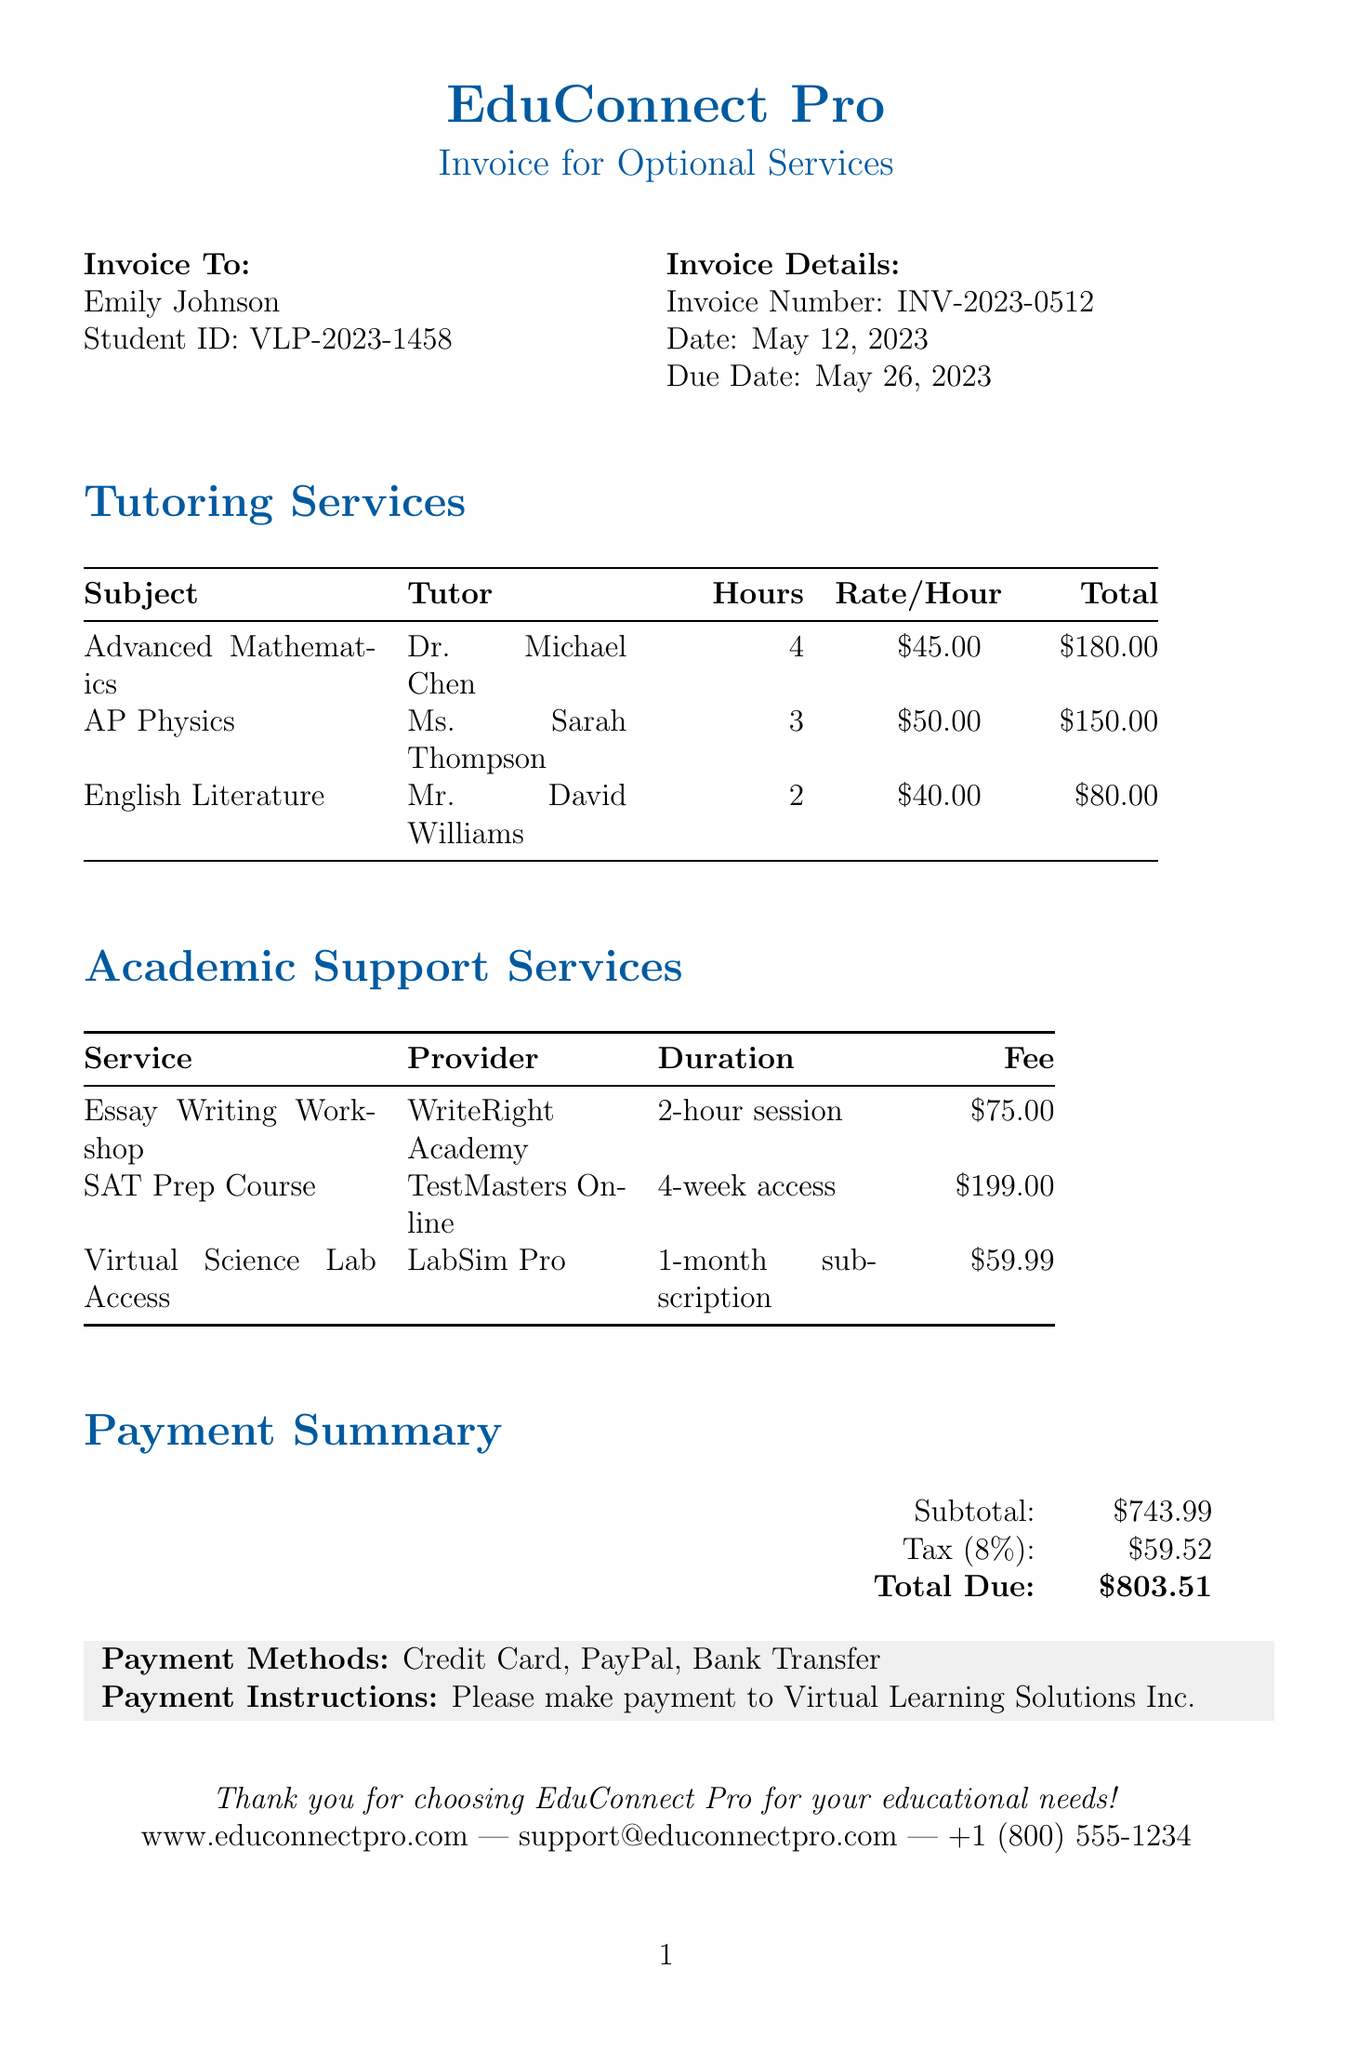What is the invoice number? The invoice number is listed at the top of the document, specifically under "Invoice Details."
Answer: INV-2023-0512 Who provided the SAT Prep Course? The provider of the SAT Prep Course is mentioned in the "Academic Support Services" section.
Answer: TestMasters Online How many hours of Advanced Mathematics tutoring were provided? The number of hours is detailed in the "Tutoring Services" section for Advanced Mathematics.
Answer: 4 What is the fee for the Essay Writing Workshop? The fee is specified in the "Academic Support Services" section for the Essay Writing Workshop.
Answer: $75.00 What is the total due amount? The total due is indicated in the "Payment Summary" section at the end of the document.
Answer: $803.51 Who was the tutor for English Literature? The tutor's name is stated in the "Tutoring Services" section for English Literature.
Answer: Mr. David Williams How much tax is included in the invoice? The tax amount is provided in the "Payment Summary" section.
Answer: $59.52 What payment methods are accepted? The payment methods are enumerated in a specific box towards the bottom of the invoice.
Answer: Credit Card, PayPal, Bank Transfer 